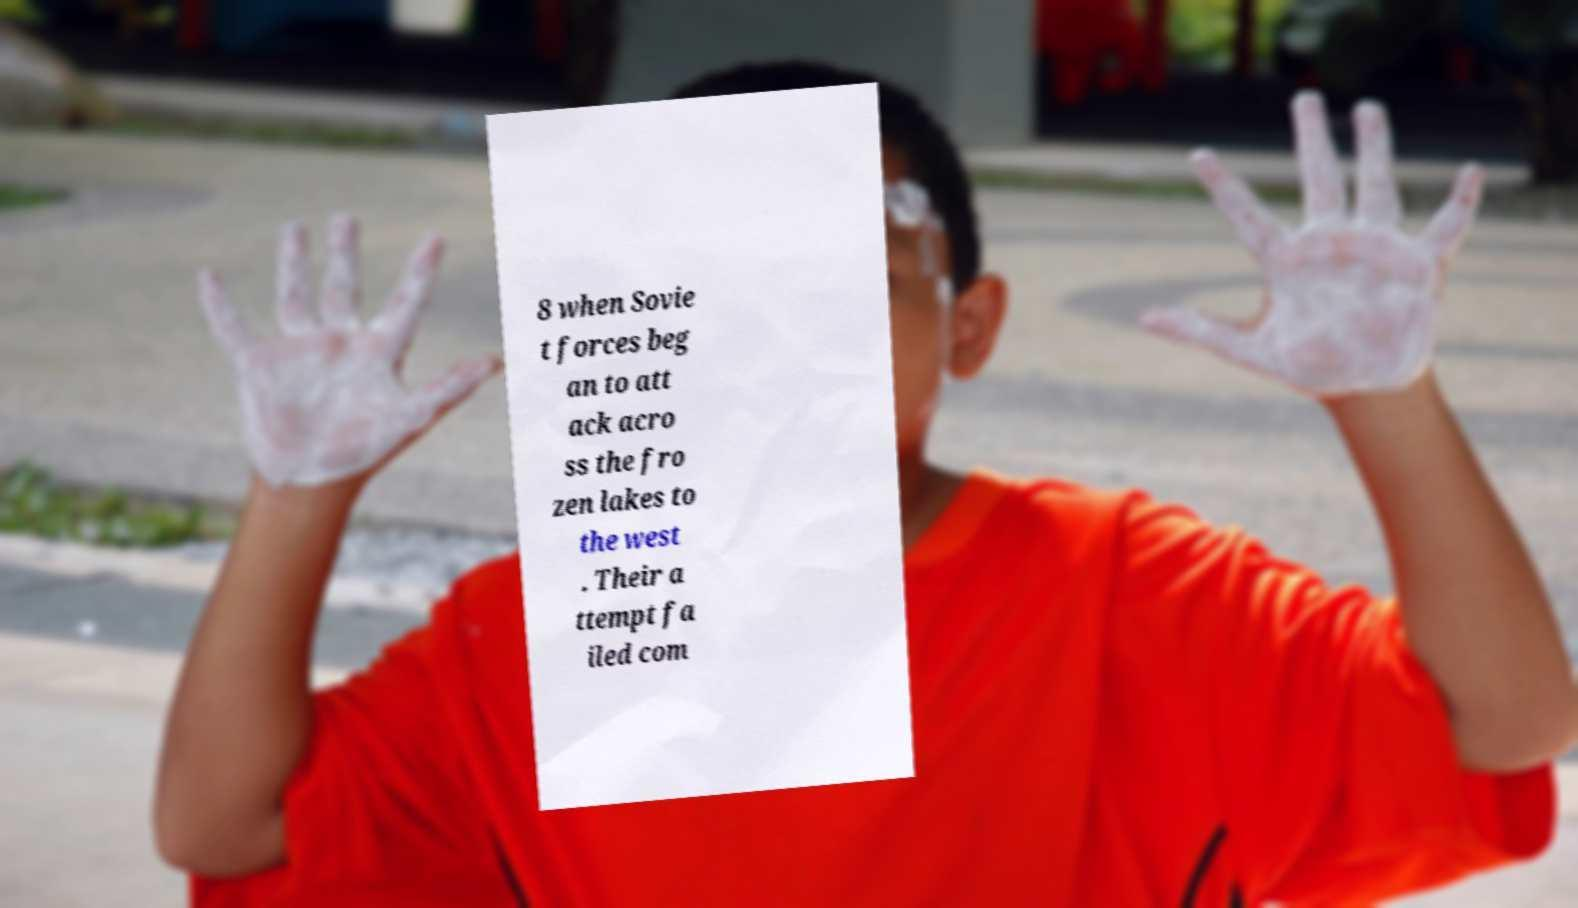What messages or text are displayed in this image? I need them in a readable, typed format. 8 when Sovie t forces beg an to att ack acro ss the fro zen lakes to the west . Their a ttempt fa iled com 